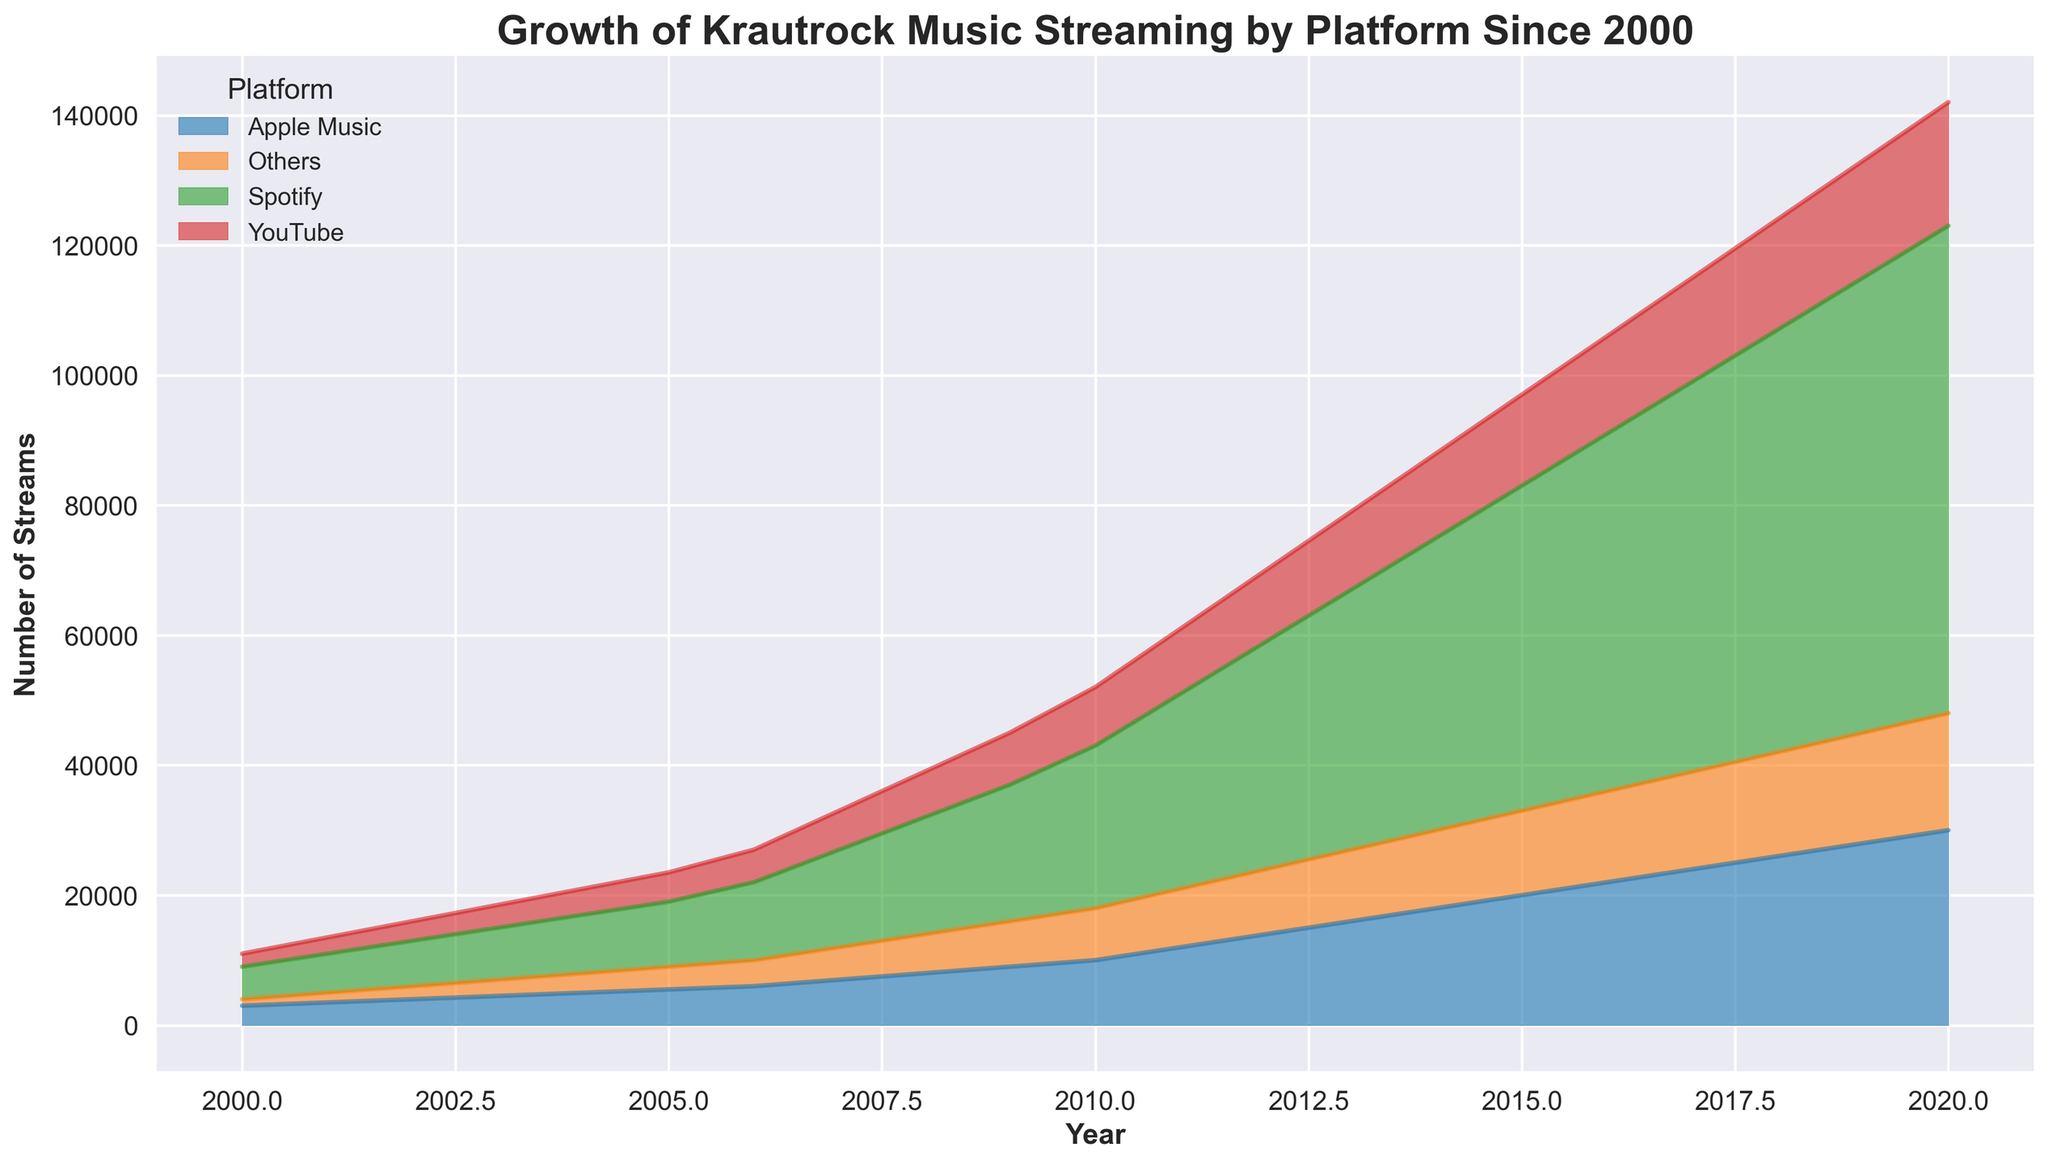What was the total number of streams across all platforms in 2010? Add the number of streams for each platform in 2010: Spotify (25000), Apple Music (10000), YouTube (9000), and Others (8000). Total streams = 25000 + 10000 + 9000 + 8000 = 52000
Answer: 52000 Which platform had the highest number of streams in 2008? Compare the number of streams for each platform in 2008: Spotify (18000), Apple Music (8000), YouTube (7000), and Others (6000). Spotify has the highest number of streams
Answer: Spotify How did the number of streams on YouTube change from 2005 to 2010? Subtract the 2005 YouTube streams (4500) from the 2010 YouTube streams (9000). Change = 9000 - 4500 = 4500
Answer: 4500 increase What is the trend of Spotify streams from 2000 to 2020? From 2000 to 2020, Spotify streams increase each year starting at 5000 in 2000 and reaching 75000 in 2020. This indicates a consistent upward trend
Answer: Increasing By how much did Apple Music streams increase from 2000 to 2020? Subtract the streams in 2000 (3000) from the streams in 2020 (30000) for Apple Music. Increase = 30000 - 3000 = 27000
Answer: 27000 In which year did 'Others' first reach 7000 streams? According to the data, 'Others' first reached 7000 streams in 2009
Answer: 2009 What is the approximate ratio of Spotify streams to Apple Music streams in 2015? Calculate the ratio of Spotify streams (50000) to Apple Music streams (20000) in 2015. Ratio = 50000 / 20000 = 2.5
Answer: 2.5 Which year saw the highest combined total of streams from all platforms? Calculate the combined total for each year and determine which is highest. 2020 has the highest total of 75000 + 30000 + 19000 + 18000 = 142000
Answer: 2020 In 2012, how did the number of streams on 'Others' compare to YouTube? In 2012, 'Others' has 10000 streams, and YouTube has 11000 streams. 'Others' had 1000 fewer streams
Answer: 1000 fewer What percentage of total streams did Spotify have in 2007? Calculate the total streams in 2007 (15000 + 7000 + 6000 + 5000 = 33000) and determine Spotify’s percentage. Percentage = (15000 / 33000) * 100 ≈ 45.45%
Answer: 45.45% 